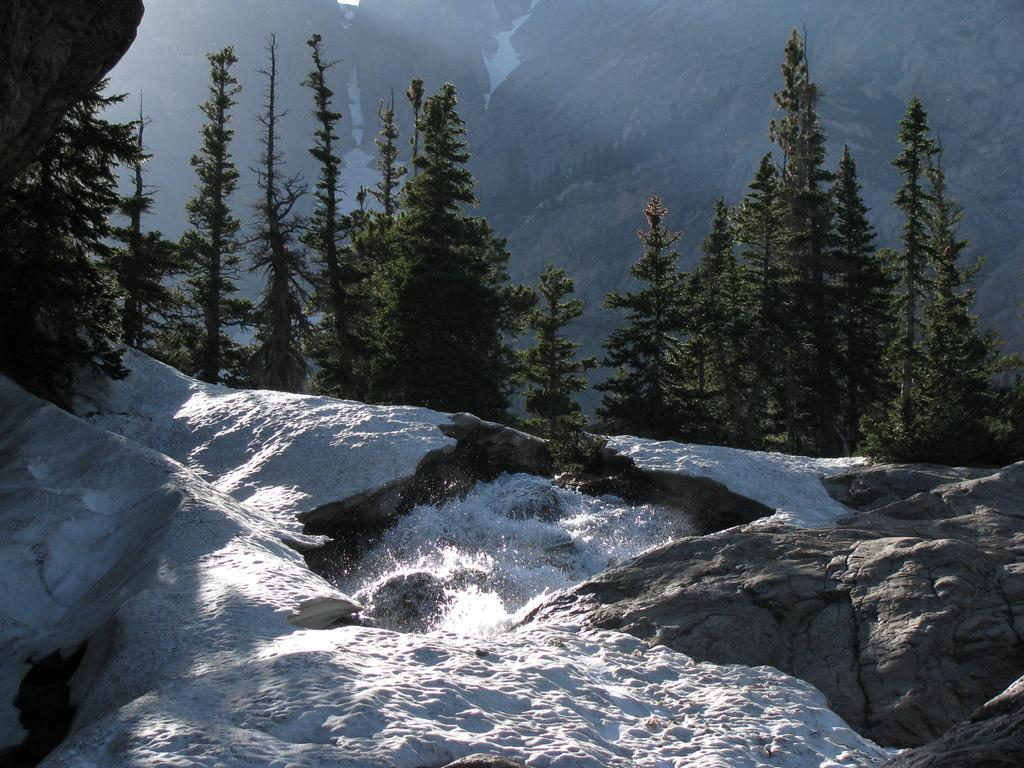What is covering the rocks in the image? There is snow on the rocks in the image. What can be seen in the distance behind the rocks? There are trees and mountains visible in the background of the image. What type of sock is being used to promote peace in the image? There is no sock or reference to promoting peace in the image. 